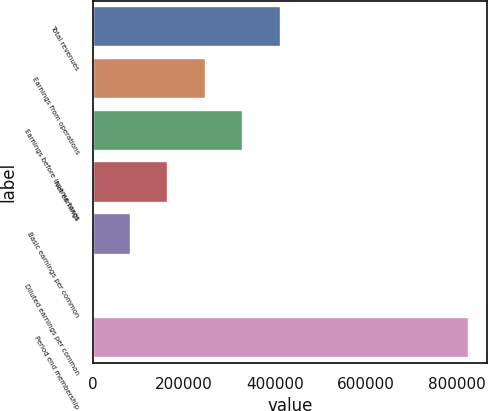<chart> <loc_0><loc_0><loc_500><loc_500><bar_chart><fcel>Total revenues<fcel>Earnings from operations<fcel>Earnings before income taxes<fcel>Net earnings<fcel>Basic earnings per common<fcel>Diluted earnings per common<fcel>Period end membership<nl><fcel>412700<fcel>247620<fcel>330160<fcel>165080<fcel>82540.3<fcel>0.34<fcel>825400<nl></chart> 